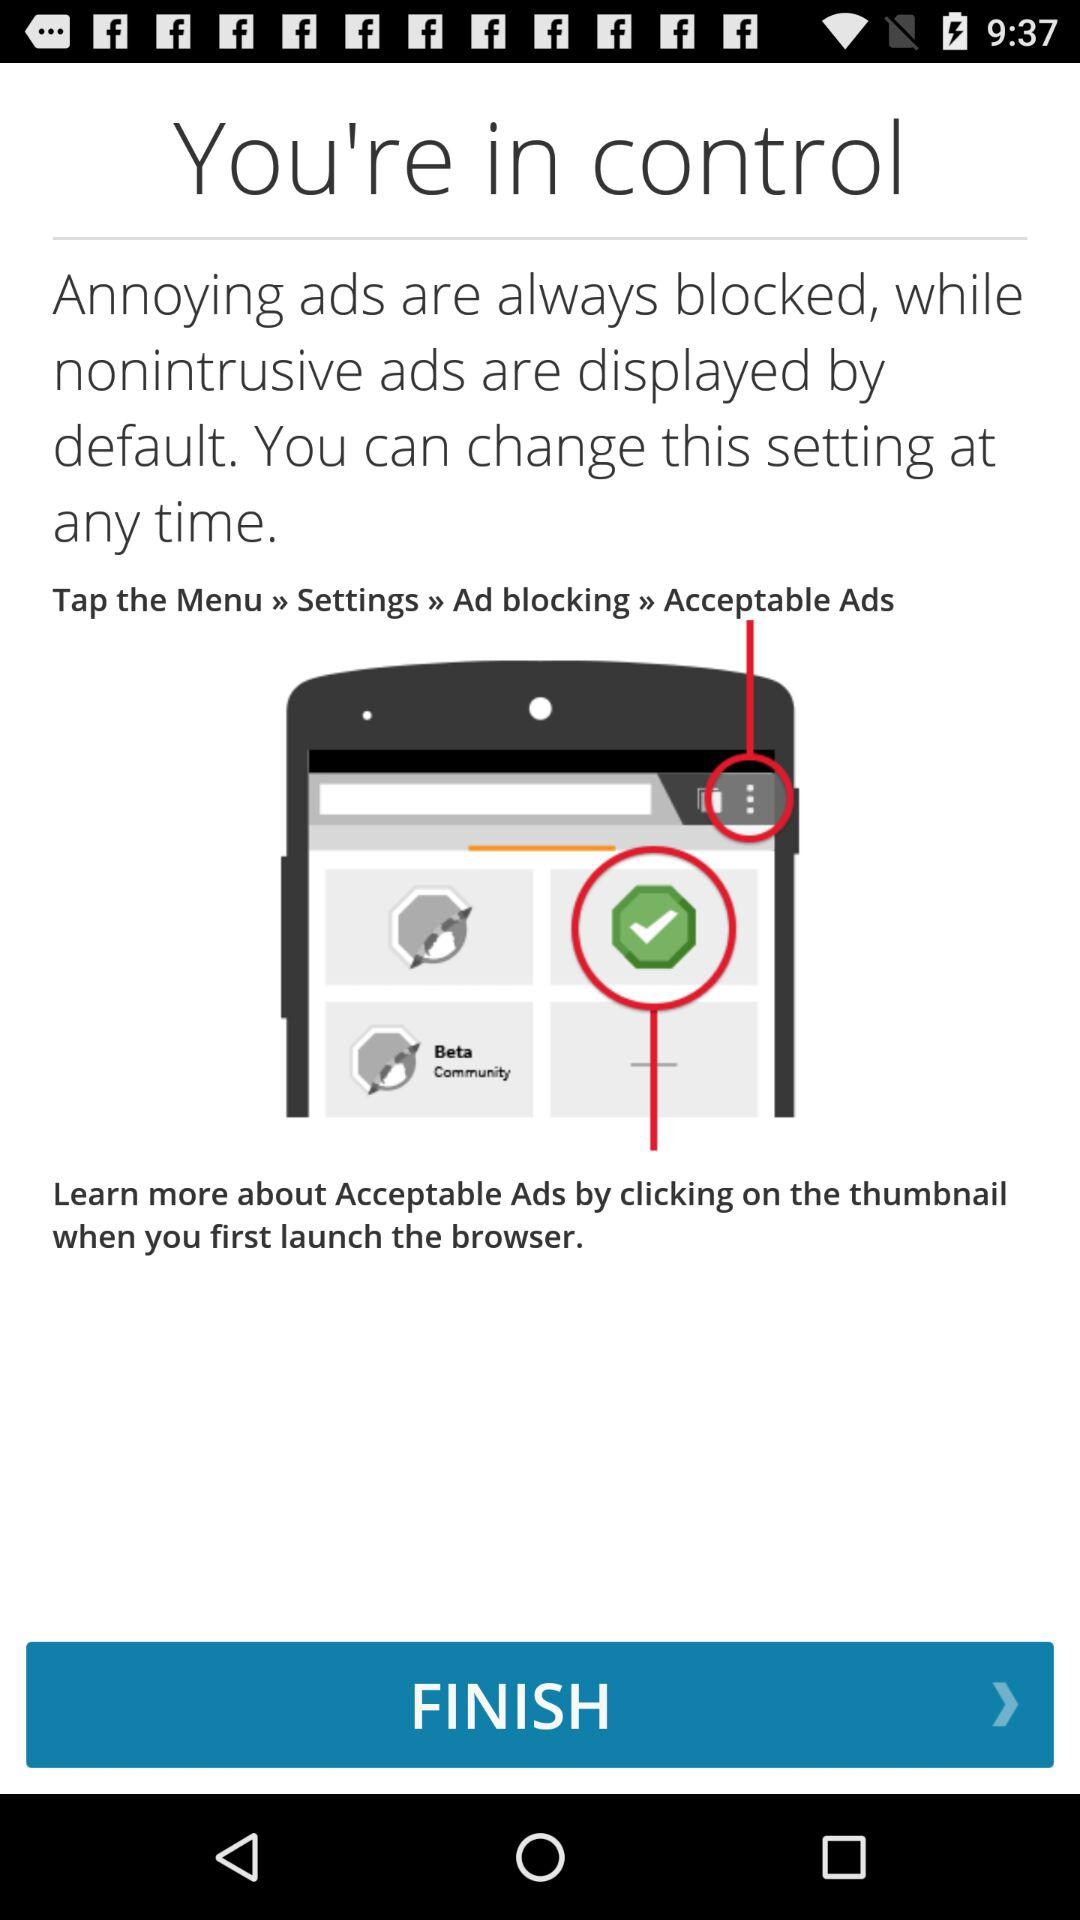How many steps are there to change the ad blocking setting?
Answer the question using a single word or phrase. 4 